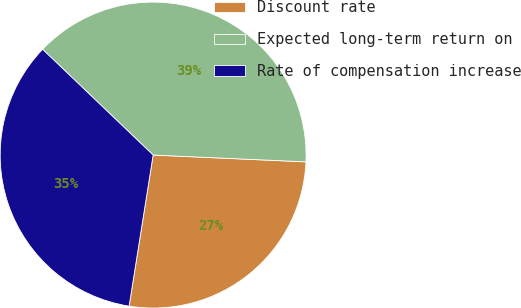Convert chart. <chart><loc_0><loc_0><loc_500><loc_500><pie_chart><fcel>Discount rate<fcel>Expected long-term return on<fcel>Rate of compensation increase<nl><fcel>26.8%<fcel>38.56%<fcel>34.64%<nl></chart> 